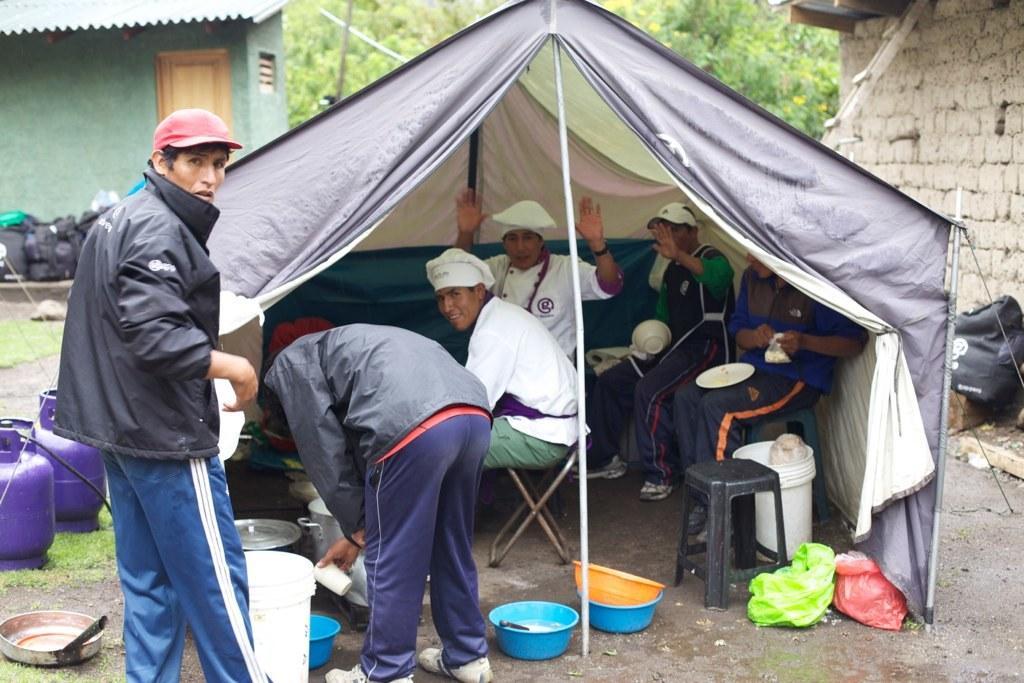How would you summarize this image in a sentence or two? In this image there are few persons sitting under a tent. Right side there is a person wearing blue shirt is having plate on his lap. He is holding a packet in his hand. Beside him there is a person sitting in chair and he is holding a bowl. Right side there is a person wearing a black jacket is standing on the land. Before him there is a person holding a cup in his hand. There are two cylinders, tubs, vessels, stoop, cover are on the land. Behind the text there are few trees. Left side there is a house. Before it there are few bags on the floor. Right side there is a brick wall having a bag beside it. 